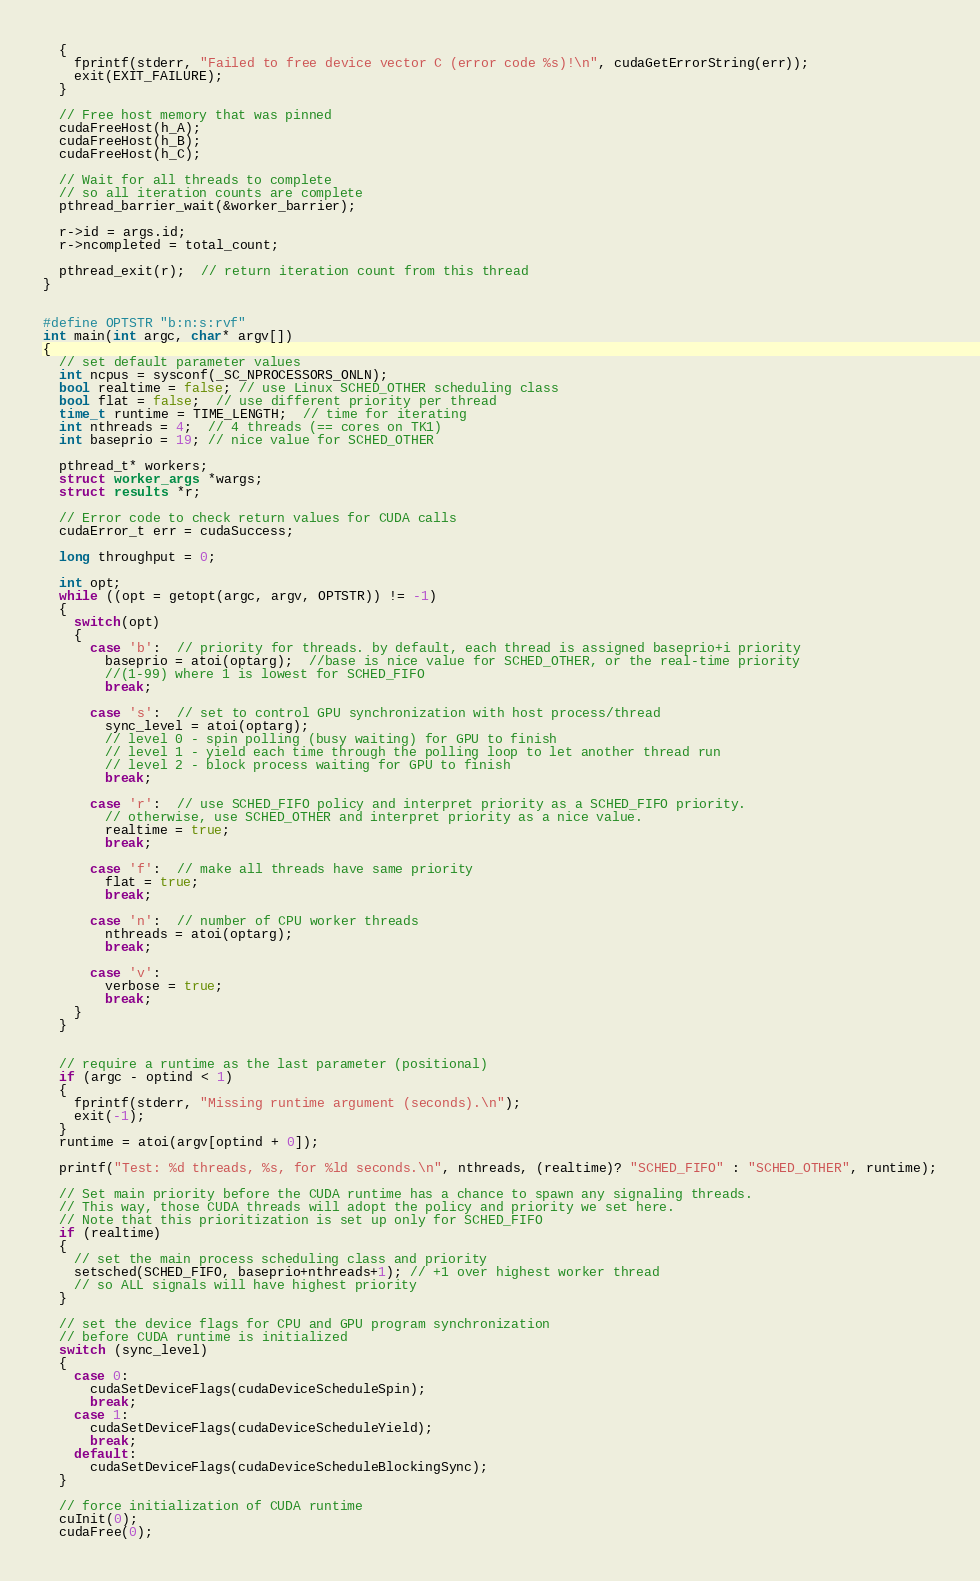<code> <loc_0><loc_0><loc_500><loc_500><_Cuda_>  {
    fprintf(stderr, "Failed to free device vector C (error code %s)!\n", cudaGetErrorString(err));
    exit(EXIT_FAILURE);
  }

  // Free host memory that was pinned
  cudaFreeHost(h_A);
  cudaFreeHost(h_B);
  cudaFreeHost(h_C);

  // Wait for all threads to complete
  // so all iteration counts are complete
  pthread_barrier_wait(&worker_barrier);

  r->id = args.id;
  r->ncompleted = total_count;

  pthread_exit(r);  // return iteration count from this thread
}


#define OPTSTR "b:n:s:rvf"
int main(int argc, char* argv[])
{
  // set default parameter values
  int ncpus = sysconf(_SC_NPROCESSORS_ONLN);
  bool realtime = false; // use Linux SCHED_OTHER scheduling class
  bool flat = false;  // use different priority per thread
  time_t runtime = TIME_LENGTH;  // time for iterating
  int nthreads = 4;  // 4 threads (== cores on TK1)
  int baseprio = 19; // nice value for SCHED_OTHER

  pthread_t* workers;
  struct worker_args *wargs;
  struct results *r;

  // Error code to check return values for CUDA calls
  cudaError_t err = cudaSuccess;

  long throughput = 0;

  int opt;
  while ((opt = getopt(argc, argv, OPTSTR)) != -1)
  {
    switch(opt)
    {
      case 'b':  // priority for threads. by default, each thread is assigned baseprio+i priority
        baseprio = atoi(optarg);  //base is nice value for SCHED_OTHER, or the real-time priority
        //(1-99) where 1 is lowest for SCHED_FIFO
        break;

      case 's':  // set to control GPU synchronization with host process/thread
        sync_level = atoi(optarg);
        // level 0 - spin polling (busy waiting) for GPU to finish
        // level 1 - yield each time through the polling loop to let another thread run
        // level 2 - block process waiting for GPU to finish
        break;

      case 'r':  // use SCHED_FIFO policy and interpret priority as a SCHED_FIFO priority.
        // otherwise, use SCHED_OTHER and interpret priority as a nice value.
        realtime = true;
        break;

      case 'f':  // make all threads have same priority
        flat = true;
        break;

      case 'n':  // number of CPU worker threads
        nthreads = atoi(optarg);
        break;

      case 'v':
        verbose = true;
        break;
    }
  }


  // require a runtime as the last parameter (positional)
  if (argc - optind < 1)
  {
    fprintf(stderr, "Missing runtime argument (seconds).\n");
    exit(-1);
  }
  runtime = atoi(argv[optind + 0]);

  printf("Test: %d threads, %s, for %ld seconds.\n", nthreads, (realtime)? "SCHED_FIFO" : "SCHED_OTHER", runtime);

  // Set main priority before the CUDA runtime has a chance to spawn any signaling threads.
  // This way, those CUDA threads will adopt the policy and priority we set here.
  // Note that this prioritization is set up only for SCHED_FIFO
  if (realtime)
  {
    // set the main process scheduling class and priority
    setsched(SCHED_FIFO, baseprio+nthreads+1); // +1 over highest worker thread
    // so ALL signals will have highest priority
  }

  // set the device flags for CPU and GPU program synchronization
  // before CUDA runtime is initialized
  switch (sync_level)
  {
    case 0:
      cudaSetDeviceFlags(cudaDeviceScheduleSpin);
      break;
    case 1:
      cudaSetDeviceFlags(cudaDeviceScheduleYield);
      break;
    default:
      cudaSetDeviceFlags(cudaDeviceScheduleBlockingSync);
  }

  // force initialization of CUDA runtime
  cuInit(0);
  cudaFree(0);
</code> 